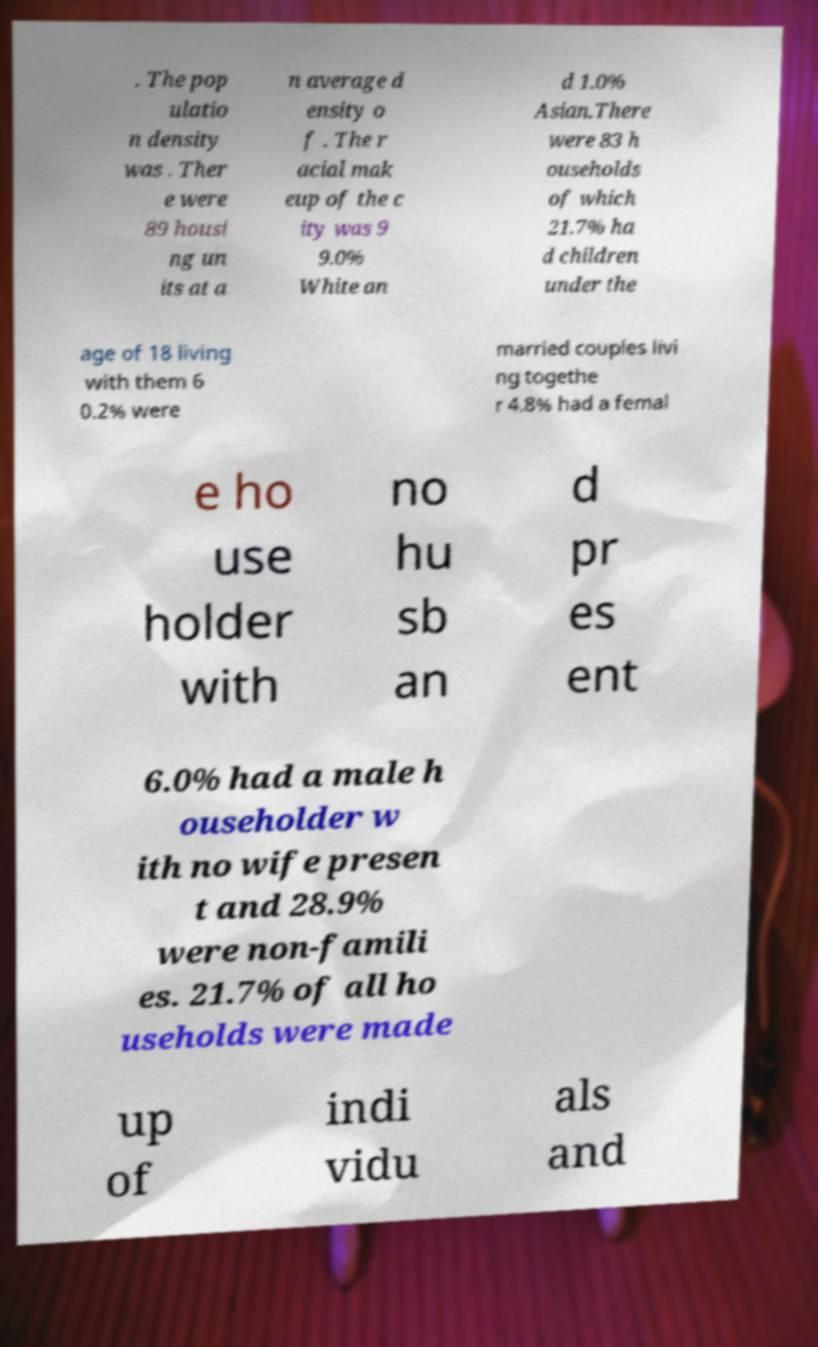Could you assist in decoding the text presented in this image and type it out clearly? . The pop ulatio n density was . Ther e were 89 housi ng un its at a n average d ensity o f . The r acial mak eup of the c ity was 9 9.0% White an d 1.0% Asian.There were 83 h ouseholds of which 21.7% ha d children under the age of 18 living with them 6 0.2% were married couples livi ng togethe r 4.8% had a femal e ho use holder with no hu sb an d pr es ent 6.0% had a male h ouseholder w ith no wife presen t and 28.9% were non-famili es. 21.7% of all ho useholds were made up of indi vidu als and 